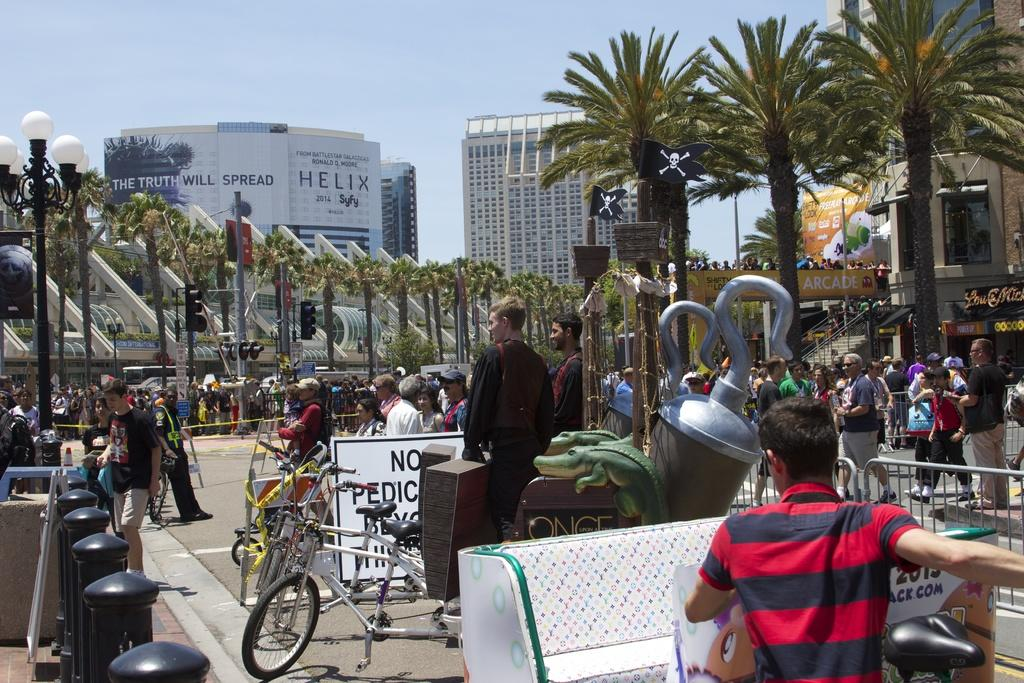<image>
Write a terse but informative summary of the picture. A busy street with an awning that says Arcade. 